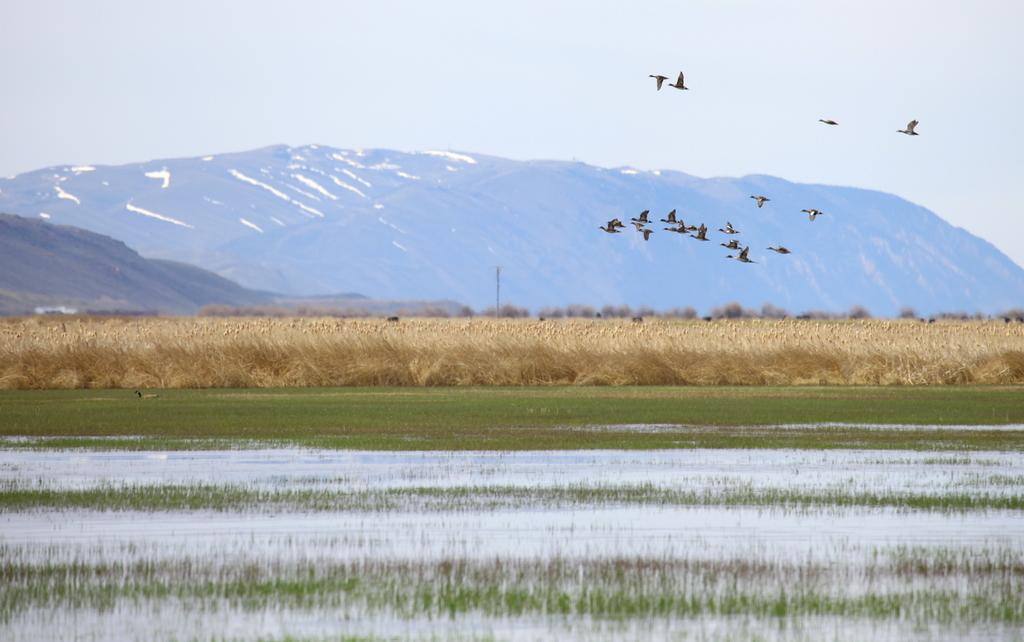What is one of the natural elements present in the image? There is water in the image. What type of vegetation can be seen in the image? There is grass in the image. What type of animals are present in the image? There is cattle in the image. What is happening in the sky in the image? Birds are flying in the sky in the image. What can be seen in the distance in the image? There are mountains visible in the background of the image. Where is the judge sitting in the image? There is no judge present in the image. What type of ball can be seen bouncing in the image? There is no ball present in the image. 